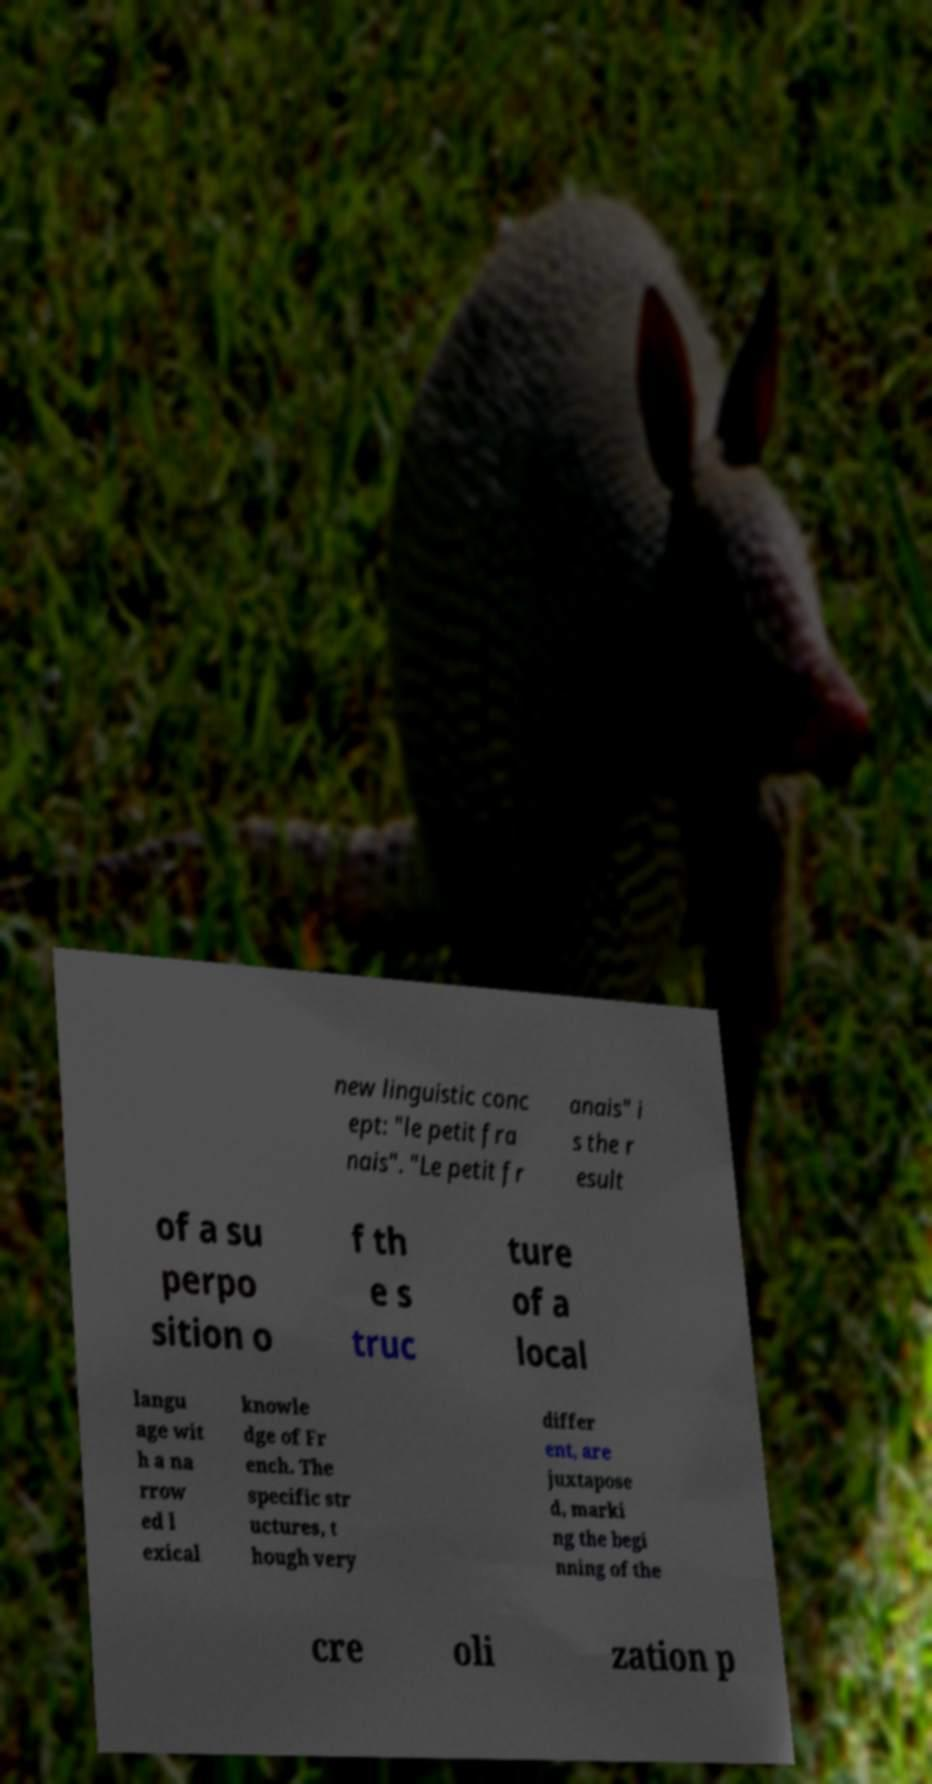Can you read and provide the text displayed in the image?This photo seems to have some interesting text. Can you extract and type it out for me? new linguistic conc ept: "le petit fra nais". "Le petit fr anais" i s the r esult of a su perpo sition o f th e s truc ture of a local langu age wit h a na rrow ed l exical knowle dge of Fr ench. The specific str uctures, t hough very differ ent, are juxtapose d, marki ng the begi nning of the cre oli zation p 